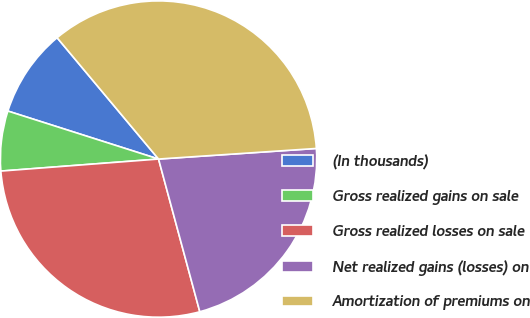Convert chart. <chart><loc_0><loc_0><loc_500><loc_500><pie_chart><fcel>(In thousands)<fcel>Gross realized gains on sale<fcel>Gross realized losses on sale<fcel>Net realized gains (losses) on<fcel>Amortization of premiums on<nl><fcel>9.01%<fcel>6.12%<fcel>27.99%<fcel>21.87%<fcel>35.02%<nl></chart> 